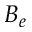<formula> <loc_0><loc_0><loc_500><loc_500>B _ { e }</formula> 